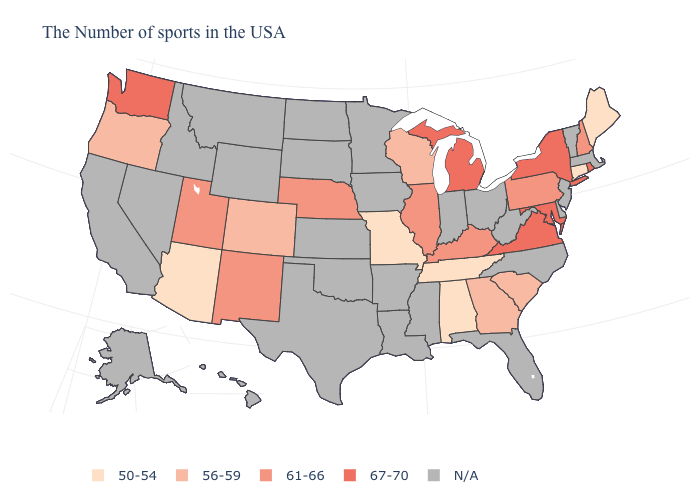What is the value of Maryland?
Answer briefly. 67-70. Name the states that have a value in the range 67-70?
Concise answer only. Rhode Island, New York, Maryland, Virginia, Michigan, Washington. Name the states that have a value in the range N/A?
Answer briefly. Massachusetts, Vermont, New Jersey, Delaware, North Carolina, West Virginia, Ohio, Florida, Indiana, Mississippi, Louisiana, Arkansas, Minnesota, Iowa, Kansas, Oklahoma, Texas, South Dakota, North Dakota, Wyoming, Montana, Idaho, Nevada, California, Alaska, Hawaii. What is the value of Virginia?
Keep it brief. 67-70. What is the highest value in the South ?
Be succinct. 67-70. Name the states that have a value in the range 67-70?
Give a very brief answer. Rhode Island, New York, Maryland, Virginia, Michigan, Washington. What is the highest value in the USA?
Be succinct. 67-70. Is the legend a continuous bar?
Give a very brief answer. No. Which states hav the highest value in the Northeast?
Short answer required. Rhode Island, New York. Does the map have missing data?
Be succinct. Yes. What is the value of South Carolina?
Quick response, please. 56-59. Name the states that have a value in the range 61-66?
Be succinct. New Hampshire, Pennsylvania, Kentucky, Illinois, Nebraska, New Mexico, Utah. Name the states that have a value in the range 61-66?
Quick response, please. New Hampshire, Pennsylvania, Kentucky, Illinois, Nebraska, New Mexico, Utah. Among the states that border Tennessee , does Georgia have the highest value?
Short answer required. No. 